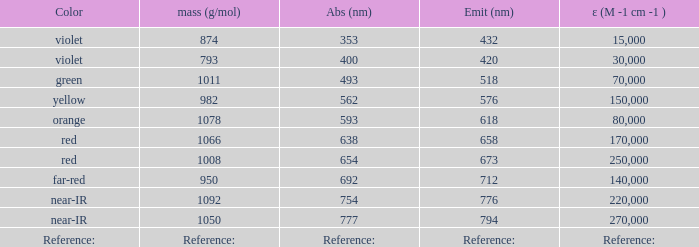What is the Absorbtion (in nanometers) of the color Violet with an emission of 432 nm? 353.0. 